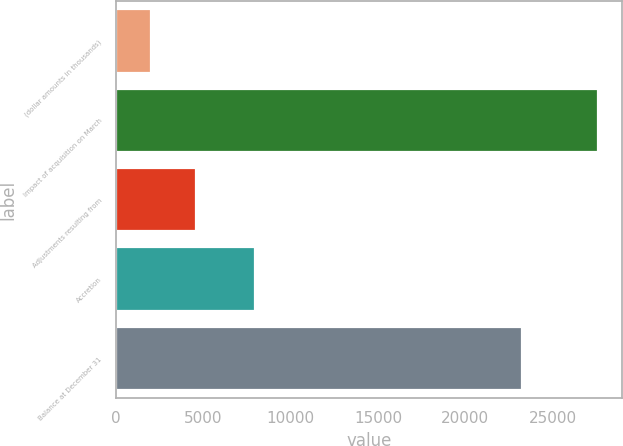<chart> <loc_0><loc_0><loc_500><loc_500><bar_chart><fcel>(dollar amounts in thousands)<fcel>Impact of acquisition on March<fcel>Adjustments resulting from<fcel>Accretion<fcel>Balance at December 31<nl><fcel>2012<fcel>27586<fcel>4569.4<fcel>7960<fcel>23251<nl></chart> 